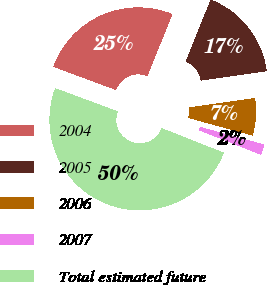Convert chart. <chart><loc_0><loc_0><loc_500><loc_500><pie_chart><fcel>2004<fcel>2005<fcel>2006<fcel>2007<fcel>Total estimated future<nl><fcel>25.46%<fcel>16.64%<fcel>6.52%<fcel>1.73%<fcel>49.65%<nl></chart> 